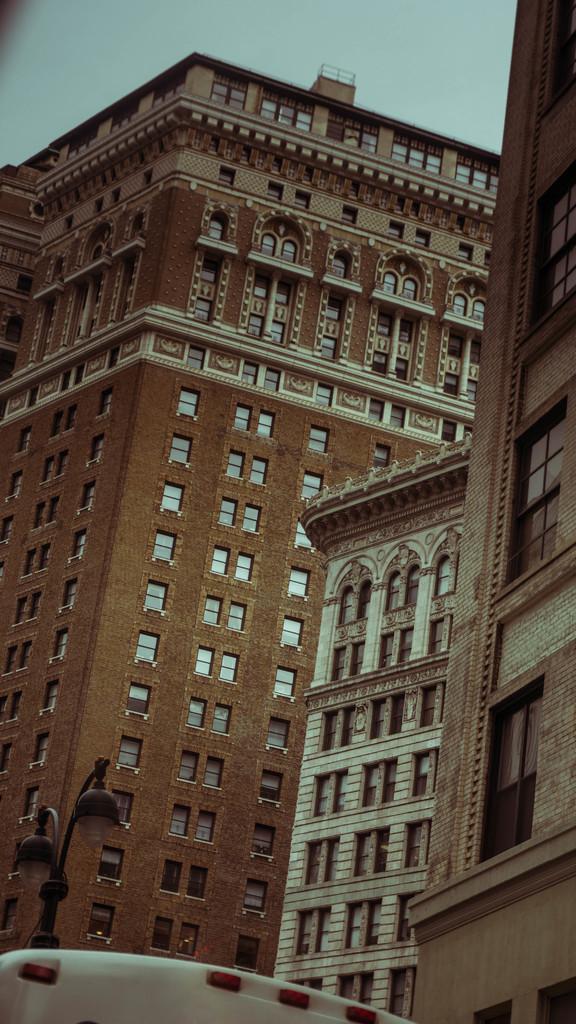Describe this image in one or two sentences. This picture might be taken from outside of the building. In this image, on the left side, we can see a street light. In the middle of the image, we can see a white color board. In the background, we can see some buildings, glass window. At the top, we can see a sky. 